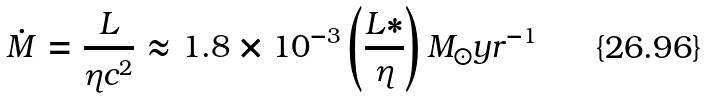<formula> <loc_0><loc_0><loc_500><loc_500>\dot { M } = \frac { L } { \eta c ^ { 2 } } \approx 1 . 8 \times 1 0 ^ { - 3 } \left ( \frac { L * } { \eta } \right ) M _ { \odot } y r ^ { - 1 }</formula> 